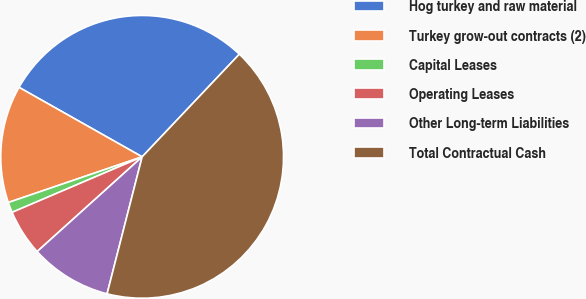Convert chart to OTSL. <chart><loc_0><loc_0><loc_500><loc_500><pie_chart><fcel>Hog turkey and raw material<fcel>Turkey grow-out contracts (2)<fcel>Capital Leases<fcel>Operating Leases<fcel>Other Long-term Liabilities<fcel>Total Contractual Cash<nl><fcel>28.89%<fcel>13.41%<fcel>1.19%<fcel>5.26%<fcel>9.33%<fcel>41.92%<nl></chart> 